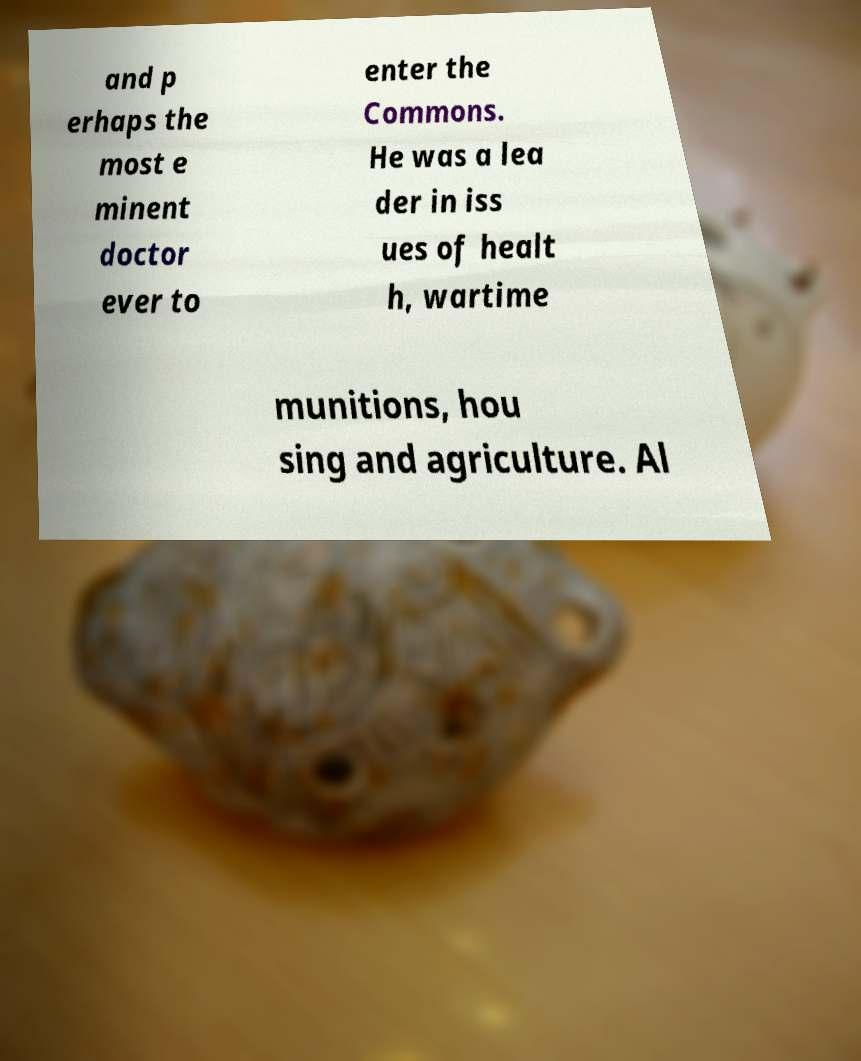Could you assist in decoding the text presented in this image and type it out clearly? and p erhaps the most e minent doctor ever to enter the Commons. He was a lea der in iss ues of healt h, wartime munitions, hou sing and agriculture. Al 